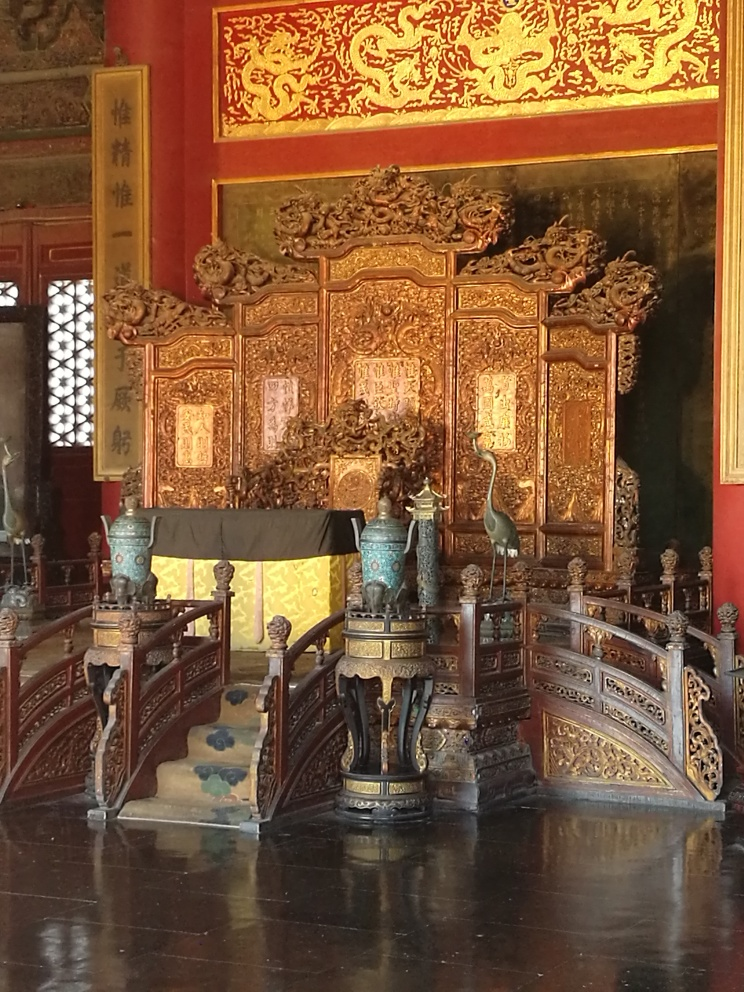How is the focus of the photo? The focus of the photo is sharp, capturing the intricate details and textures of the ornate throne and surrounding artifacts with good clarity. The depth of field is also well-managed, keeping the main subject in clear view while subtly softening the background. 